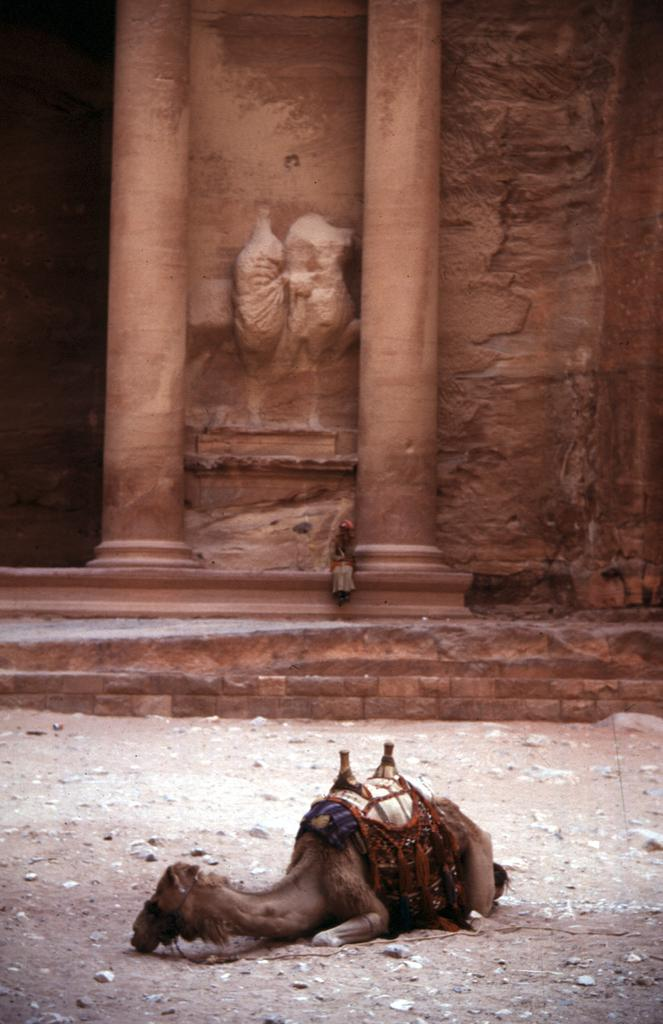What animal is lying on the land in the image? There is a camel lying on the land in the image. What is the person in the image doing? The person is sitting beside a pillar in the image. What can be seen in the background of the image? There is a wall with carvings in the background of the image. What type of bread is being used to destroy the can in the image? There is no bread or can present in the image, and therefore no such activity can be observed. 